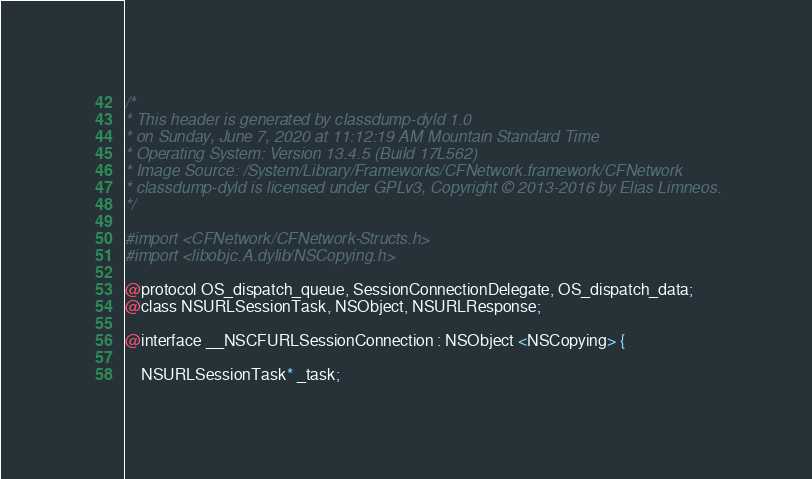<code> <loc_0><loc_0><loc_500><loc_500><_C_>/*
* This header is generated by classdump-dyld 1.0
* on Sunday, June 7, 2020 at 11:12:19 AM Mountain Standard Time
* Operating System: Version 13.4.5 (Build 17L562)
* Image Source: /System/Library/Frameworks/CFNetwork.framework/CFNetwork
* classdump-dyld is licensed under GPLv3, Copyright © 2013-2016 by Elias Limneos.
*/

#import <CFNetwork/CFNetwork-Structs.h>
#import <libobjc.A.dylib/NSCopying.h>

@protocol OS_dispatch_queue, SessionConnectionDelegate, OS_dispatch_data;
@class NSURLSessionTask, NSObject, NSURLResponse;

@interface __NSCFURLSessionConnection : NSObject <NSCopying> {

	NSURLSessionTask* _task;</code> 